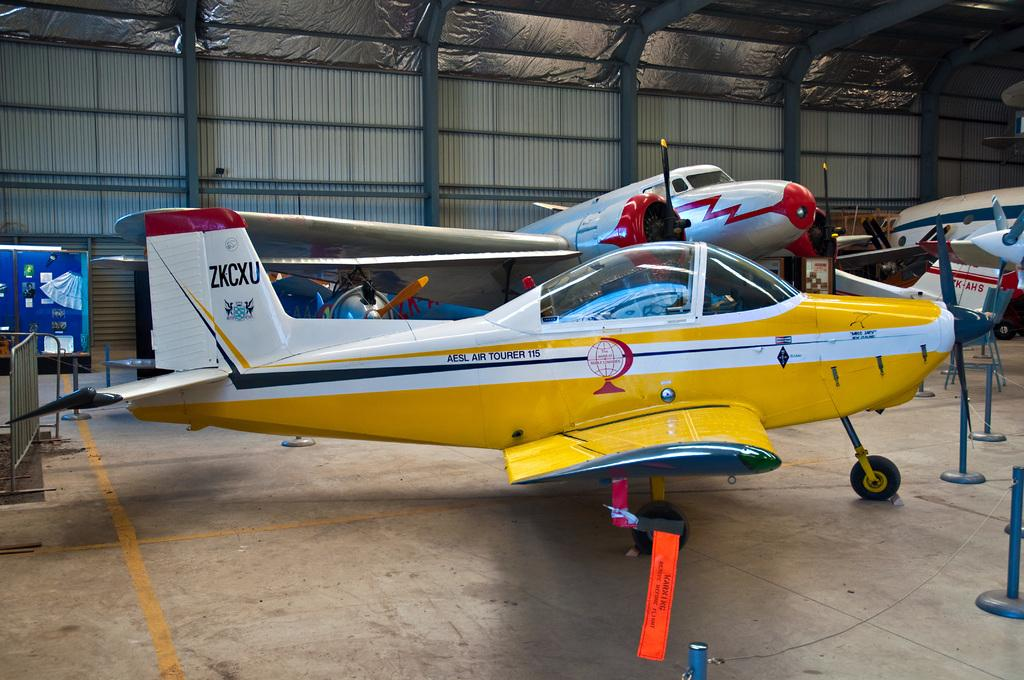What is the main subject of the image? The main subject of the image is aircraft. What can be seen on the left side of the image? There is a barricade on the left side of the image. What other objects are visible in the image? There are rods visible in the image. Can you see an owl perched on top of the aircraft in the image? No, there is no owl present in the image. 